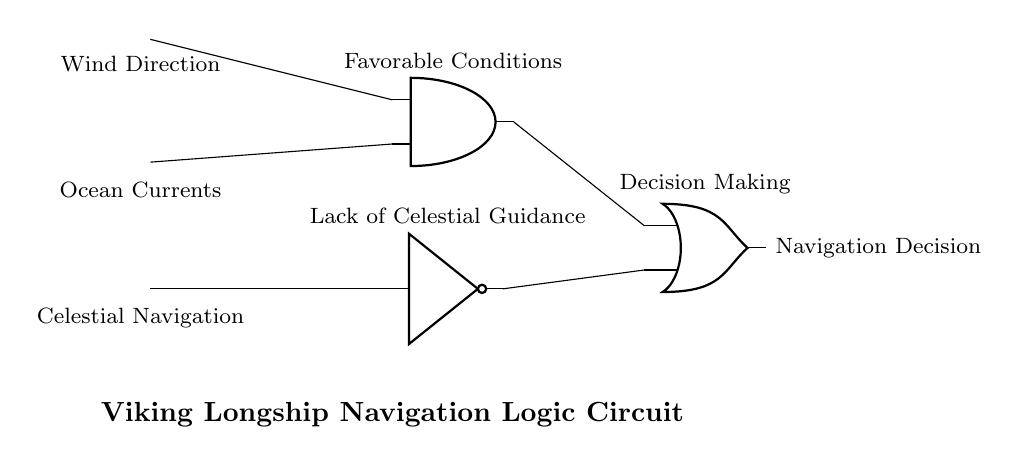What are the inputs to the AND gate? The inputs to the AND gate are Wind Direction and Ocean Currents, as shown connecting these signals to the AND gate.
Answer: Wind Direction, Ocean Currents What is the output of the NOT gate? The NOT gate takes the input from Celestial Navigation and produces the opposite value; thus, the output indicates a lack of celestial guidance.
Answer: Lack of Celestial Guidance What type of logic gate is used to determine the Navigation Decision? The Navigation Decision is determined by an OR gate, which combines the outputs of the AND gate and the NOT gate.
Answer: OR gate How many inputs does the AND gate have? The AND gate has two inputs, which are indicated by the connections made to it in the circuit.
Answer: Two What is the role of the AND gate in this circuit? The role of the AND gate is to assess whether both favorable conditions (Wind Direction and Ocean Currents) are present, necessary for navigation decision-making.
Answer: Assess favorable conditions What does the output of the OR gate represent? The output of the OR gate represents the final Navigation Decision, which results from the combination of inputs from the AND gate and the NOT gate.
Answer: Navigation Decision 